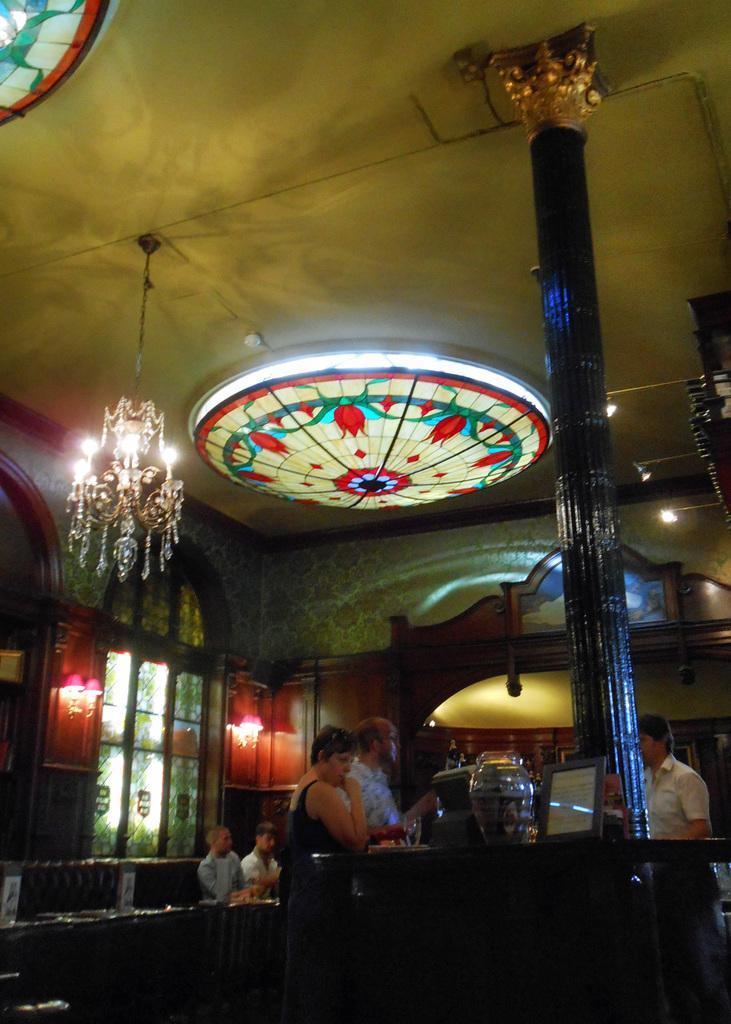In one or two sentences, can you explain what this image depicts? This picture describes about inside view of a room, in this we can find few lights and few people, in the background we can see stained glass, on the right side of the image we can see a monitor and other things on the countertop. 